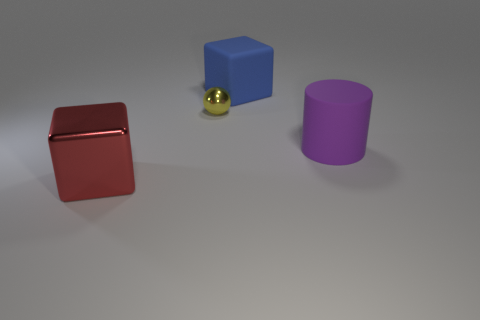Add 3 small yellow rubber objects. How many objects exist? 7 Subtract all spheres. How many objects are left? 3 Add 4 large purple rubber things. How many large purple rubber things exist? 5 Subtract 0 cyan cylinders. How many objects are left? 4 Subtract all tiny green blocks. Subtract all cylinders. How many objects are left? 3 Add 4 blue matte cubes. How many blue matte cubes are left? 5 